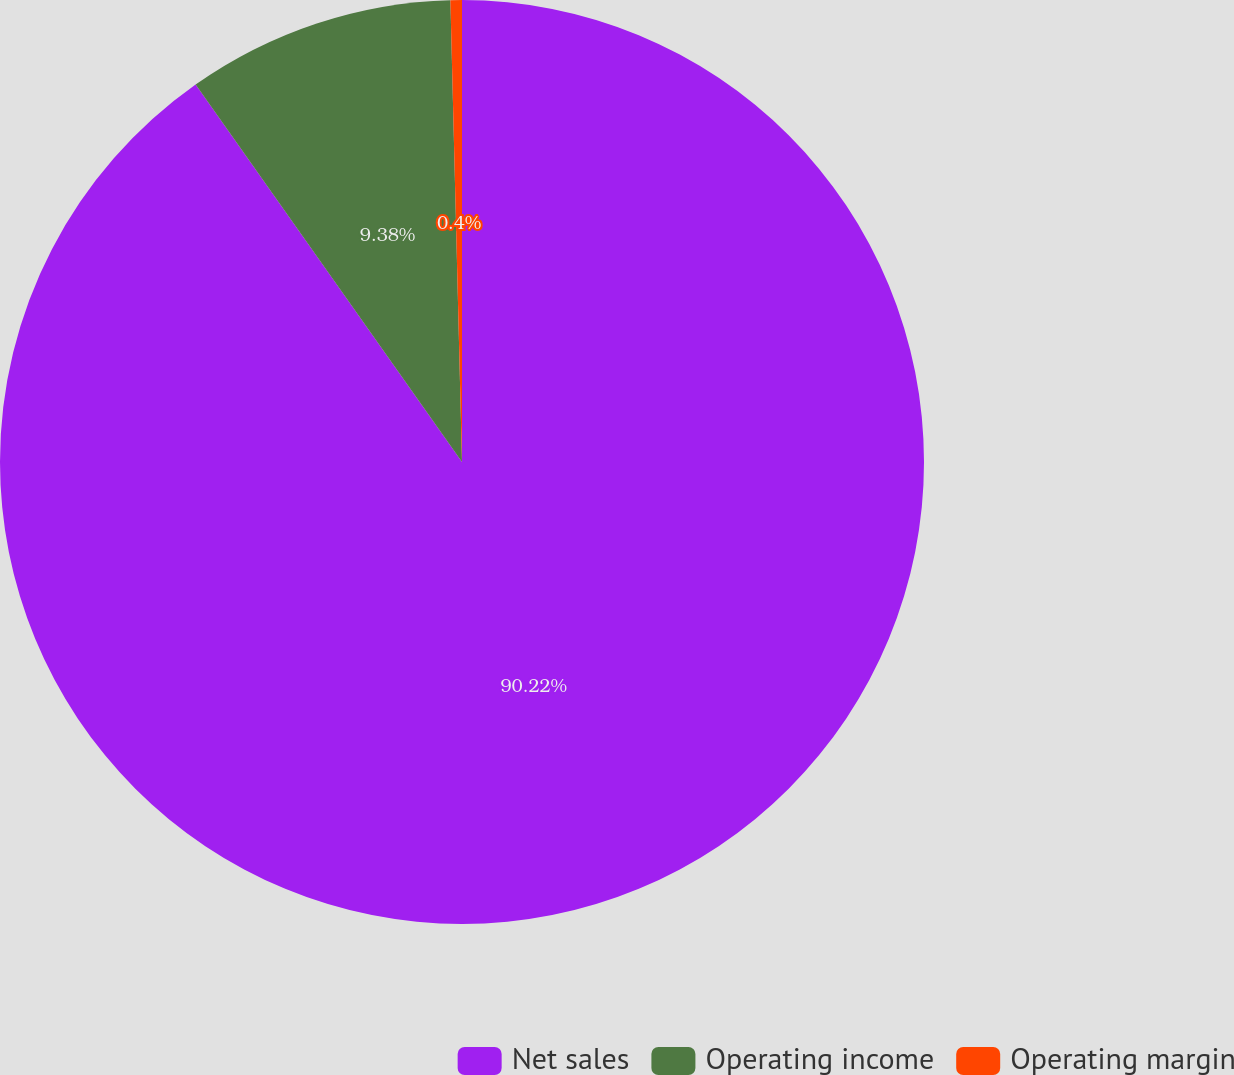<chart> <loc_0><loc_0><loc_500><loc_500><pie_chart><fcel>Net sales<fcel>Operating income<fcel>Operating margin<nl><fcel>90.21%<fcel>9.38%<fcel>0.4%<nl></chart> 